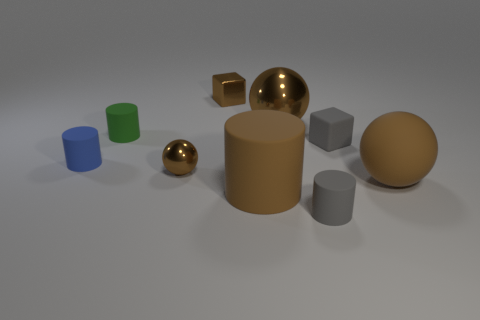What number of small cylinders are in front of the gray block and to the left of the tiny metallic block?
Offer a very short reply. 1. How many other tiny blue cylinders have the same material as the blue cylinder?
Ensure brevity in your answer.  0. There is a metallic sphere on the right side of the brown ball left of the small brown cube; how big is it?
Your answer should be compact. Large. Are there any small blue objects that have the same shape as the green object?
Provide a succinct answer. Yes. There is a brown ball on the left side of the small brown cube; is it the same size as the rubber cylinder in front of the large matte cylinder?
Offer a very short reply. Yes. Are there fewer large rubber things that are right of the big brown matte sphere than brown metallic blocks that are behind the tiny metallic cube?
Your answer should be compact. No. There is a small thing that is the same color as the rubber block; what material is it?
Provide a short and direct response. Rubber. What is the color of the small cube that is in front of the green rubber cylinder?
Give a very brief answer. Gray. Do the small rubber cube and the large metallic sphere have the same color?
Keep it short and to the point. No. There is a tiny shiny ball to the left of the tiny metallic thing behind the blue cylinder; what number of gray rubber objects are to the right of it?
Your response must be concise. 2. 